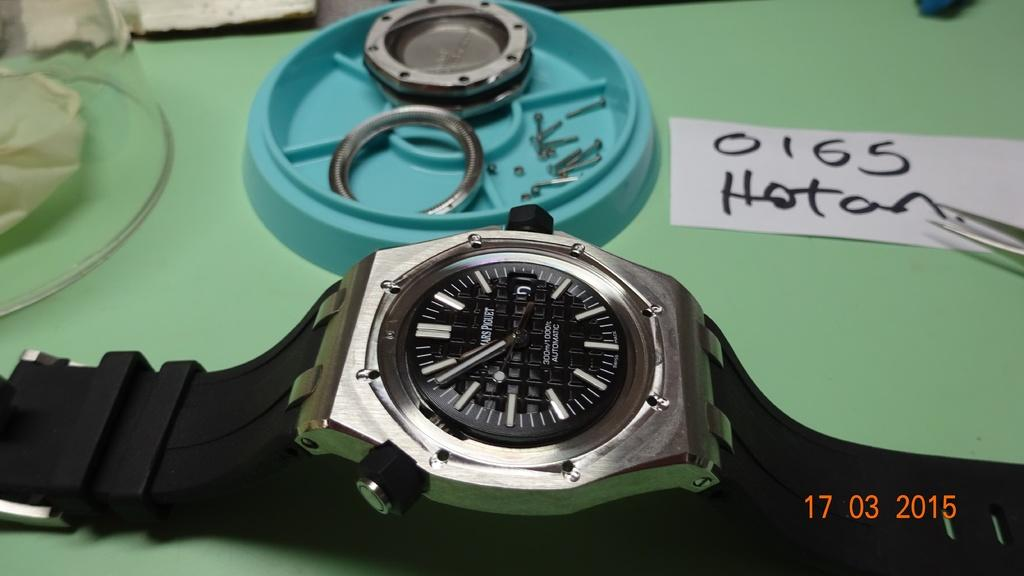<image>
Render a clear and concise summary of the photo. A watch sits next to a dish of parts and a card that says 0165. 